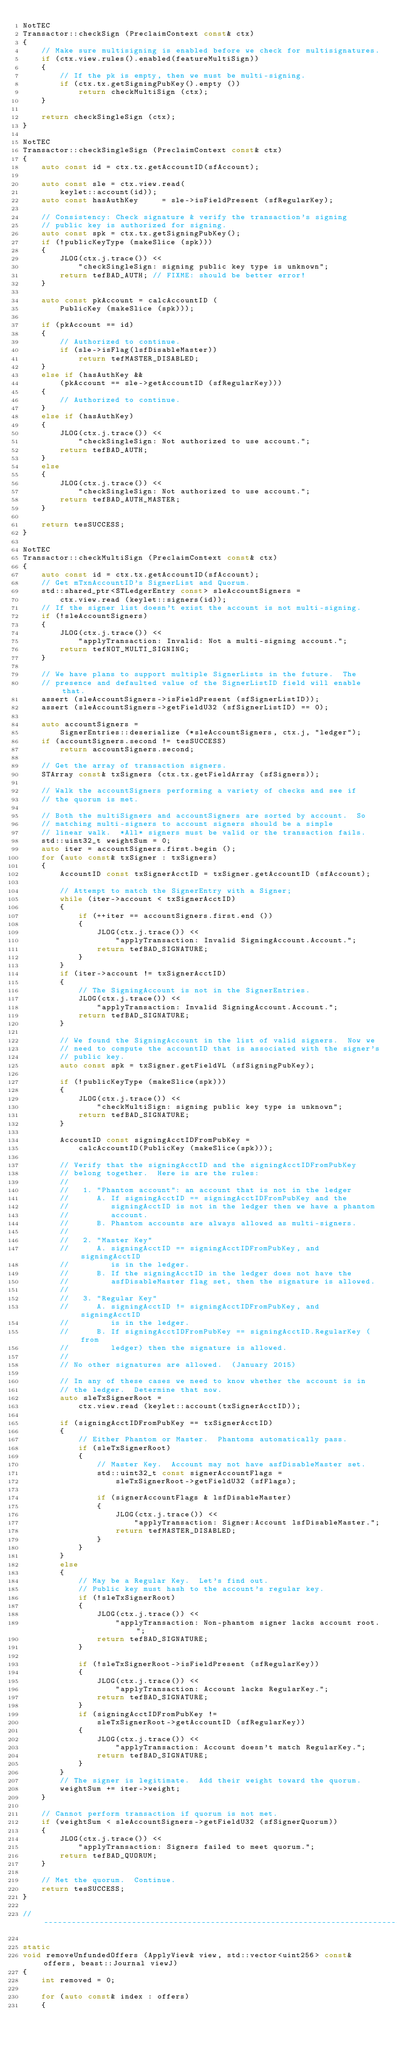<code> <loc_0><loc_0><loc_500><loc_500><_C++_>NotTEC
Transactor::checkSign (PreclaimContext const& ctx)
{
    // Make sure multisigning is enabled before we check for multisignatures.
    if (ctx.view.rules().enabled(featureMultiSign))
    {
        // If the pk is empty, then we must be multi-signing.
        if (ctx.tx.getSigningPubKey().empty ())
            return checkMultiSign (ctx);
    }

    return checkSingleSign (ctx);
}

NotTEC
Transactor::checkSingleSign (PreclaimContext const& ctx)
{
    auto const id = ctx.tx.getAccountID(sfAccount);

    auto const sle = ctx.view.read(
        keylet::account(id));
    auto const hasAuthKey     = sle->isFieldPresent (sfRegularKey);

    // Consistency: Check signature & verify the transaction's signing
    // public key is authorized for signing.
    auto const spk = ctx.tx.getSigningPubKey();
    if (!publicKeyType (makeSlice (spk)))
    {
        JLOG(ctx.j.trace()) <<
            "checkSingleSign: signing public key type is unknown";
        return tefBAD_AUTH; // FIXME: should be better error!
    }

    auto const pkAccount = calcAccountID (
        PublicKey (makeSlice (spk)));

    if (pkAccount == id)
    {
        // Authorized to continue.
        if (sle->isFlag(lsfDisableMaster))
            return tefMASTER_DISABLED;
    }
    else if (hasAuthKey &&
        (pkAccount == sle->getAccountID (sfRegularKey)))
    {
        // Authorized to continue.
    }
    else if (hasAuthKey)
    {
        JLOG(ctx.j.trace()) <<
            "checkSingleSign: Not authorized to use account.";
        return tefBAD_AUTH;
    }
    else
    {
        JLOG(ctx.j.trace()) <<
            "checkSingleSign: Not authorized to use account.";
        return tefBAD_AUTH_MASTER;
    }

    return tesSUCCESS;
}

NotTEC
Transactor::checkMultiSign (PreclaimContext const& ctx)
{
    auto const id = ctx.tx.getAccountID(sfAccount);
    // Get mTxnAccountID's SignerList and Quorum.
    std::shared_ptr<STLedgerEntry const> sleAccountSigners =
        ctx.view.read (keylet::signers(id));
    // If the signer list doesn't exist the account is not multi-signing.
    if (!sleAccountSigners)
    {
        JLOG(ctx.j.trace()) <<
            "applyTransaction: Invalid: Not a multi-signing account.";
        return tefNOT_MULTI_SIGNING;
    }

    // We have plans to support multiple SignerLists in the future.  The
    // presence and defaulted value of the SignerListID field will enable that.
    assert (sleAccountSigners->isFieldPresent (sfSignerListID));
    assert (sleAccountSigners->getFieldU32 (sfSignerListID) == 0);

    auto accountSigners =
        SignerEntries::deserialize (*sleAccountSigners, ctx.j, "ledger");
    if (accountSigners.second != tesSUCCESS)
        return accountSigners.second;

    // Get the array of transaction signers.
    STArray const& txSigners (ctx.tx.getFieldArray (sfSigners));

    // Walk the accountSigners performing a variety of checks and see if
    // the quorum is met.

    // Both the multiSigners and accountSigners are sorted by account.  So
    // matching multi-signers to account signers should be a simple
    // linear walk.  *All* signers must be valid or the transaction fails.
    std::uint32_t weightSum = 0;
    auto iter = accountSigners.first.begin ();
    for (auto const& txSigner : txSigners)
    {
        AccountID const txSignerAcctID = txSigner.getAccountID (sfAccount);

        // Attempt to match the SignerEntry with a Signer;
        while (iter->account < txSignerAcctID)
        {
            if (++iter == accountSigners.first.end ())
            {
                JLOG(ctx.j.trace()) <<
                    "applyTransaction: Invalid SigningAccount.Account.";
                return tefBAD_SIGNATURE;
            }
        }
        if (iter->account != txSignerAcctID)
        {
            // The SigningAccount is not in the SignerEntries.
            JLOG(ctx.j.trace()) <<
                "applyTransaction: Invalid SigningAccount.Account.";
            return tefBAD_SIGNATURE;
        }

        // We found the SigningAccount in the list of valid signers.  Now we
        // need to compute the accountID that is associated with the signer's
        // public key.
        auto const spk = txSigner.getFieldVL (sfSigningPubKey);

        if (!publicKeyType (makeSlice(spk)))
        {
            JLOG(ctx.j.trace()) <<
                "checkMultiSign: signing public key type is unknown";
            return tefBAD_SIGNATURE;
        }

        AccountID const signingAcctIDFromPubKey =
            calcAccountID(PublicKey (makeSlice(spk)));

        // Verify that the signingAcctID and the signingAcctIDFromPubKey
        // belong together.  Here is are the rules:
        //
        //   1. "Phantom account": an account that is not in the ledger
        //      A. If signingAcctID == signingAcctIDFromPubKey and the
        //         signingAcctID is not in the ledger then we have a phantom
        //         account.
        //      B. Phantom accounts are always allowed as multi-signers.
        //
        //   2. "Master Key"
        //      A. signingAcctID == signingAcctIDFromPubKey, and signingAcctID
        //         is in the ledger.
        //      B. If the signingAcctID in the ledger does not have the
        //         asfDisableMaster flag set, then the signature is allowed.
        //
        //   3. "Regular Key"
        //      A. signingAcctID != signingAcctIDFromPubKey, and signingAcctID
        //         is in the ledger.
        //      B. If signingAcctIDFromPubKey == signingAcctID.RegularKey (from
        //         ledger) then the signature is allowed.
        //
        // No other signatures are allowed.  (January 2015)

        // In any of these cases we need to know whether the account is in
        // the ledger.  Determine that now.
        auto sleTxSignerRoot =
            ctx.view.read (keylet::account(txSignerAcctID));

        if (signingAcctIDFromPubKey == txSignerAcctID)
        {
            // Either Phantom or Master.  Phantoms automatically pass.
            if (sleTxSignerRoot)
            {
                // Master Key.  Account may not have asfDisableMaster set.
                std::uint32_t const signerAccountFlags =
                    sleTxSignerRoot->getFieldU32 (sfFlags);

                if (signerAccountFlags & lsfDisableMaster)
                {
                    JLOG(ctx.j.trace()) <<
                        "applyTransaction: Signer:Account lsfDisableMaster.";
                    return tefMASTER_DISABLED;
                }
            }
        }
        else
        {
            // May be a Regular Key.  Let's find out.
            // Public key must hash to the account's regular key.
            if (!sleTxSignerRoot)
            {
                JLOG(ctx.j.trace()) <<
                    "applyTransaction: Non-phantom signer lacks account root.";
                return tefBAD_SIGNATURE;
            }

            if (!sleTxSignerRoot->isFieldPresent (sfRegularKey))
            {
                JLOG(ctx.j.trace()) <<
                    "applyTransaction: Account lacks RegularKey.";
                return tefBAD_SIGNATURE;
            }
            if (signingAcctIDFromPubKey !=
                sleTxSignerRoot->getAccountID (sfRegularKey))
            {
                JLOG(ctx.j.trace()) <<
                    "applyTransaction: Account doesn't match RegularKey.";
                return tefBAD_SIGNATURE;
            }
        }
        // The signer is legitimate.  Add their weight toward the quorum.
        weightSum += iter->weight;
    }

    // Cannot perform transaction if quorum is not met.
    if (weightSum < sleAccountSigners->getFieldU32 (sfSignerQuorum))
    {
        JLOG(ctx.j.trace()) <<
            "applyTransaction: Signers failed to meet quorum.";
        return tefBAD_QUORUM;
    }

    // Met the quorum.  Continue.
    return tesSUCCESS;
}

//------------------------------------------------------------------------------

static
void removeUnfundedOffers (ApplyView& view, std::vector<uint256> const& offers, beast::Journal viewJ)
{
    int removed = 0;

    for (auto const& index : offers)
    {</code> 